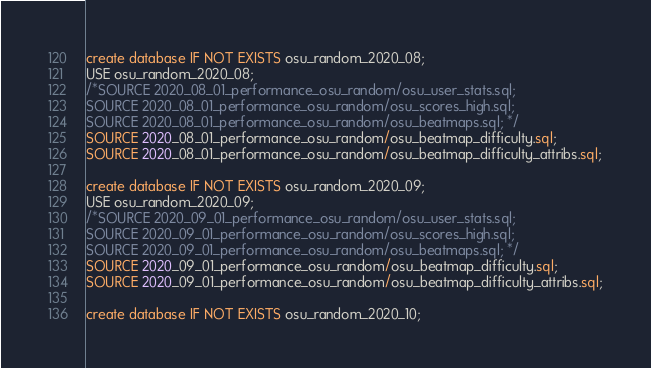Convert code to text. <code><loc_0><loc_0><loc_500><loc_500><_SQL_>create database IF NOT EXISTS osu_random_2020_08;
USE osu_random_2020_08;
/*SOURCE 2020_08_01_performance_osu_random/osu_user_stats.sql;
SOURCE 2020_08_01_performance_osu_random/osu_scores_high.sql;
SOURCE 2020_08_01_performance_osu_random/osu_beatmaps.sql; */
SOURCE 2020_08_01_performance_osu_random/osu_beatmap_difficulty.sql;
SOURCE 2020_08_01_performance_osu_random/osu_beatmap_difficulty_attribs.sql;

create database IF NOT EXISTS osu_random_2020_09;
USE osu_random_2020_09;
/*SOURCE 2020_09_01_performance_osu_random/osu_user_stats.sql;
SOURCE 2020_09_01_performance_osu_random/osu_scores_high.sql;
SOURCE 2020_09_01_performance_osu_random/osu_beatmaps.sql; */
SOURCE 2020_09_01_performance_osu_random/osu_beatmap_difficulty.sql;
SOURCE 2020_09_01_performance_osu_random/osu_beatmap_difficulty_attribs.sql;

create database IF NOT EXISTS osu_random_2020_10;</code> 